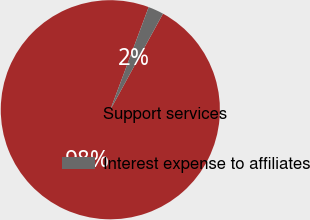Convert chart to OTSL. <chart><loc_0><loc_0><loc_500><loc_500><pie_chart><fcel>Support services<fcel>Interest expense to affiliates<nl><fcel>97.71%<fcel>2.29%<nl></chart> 